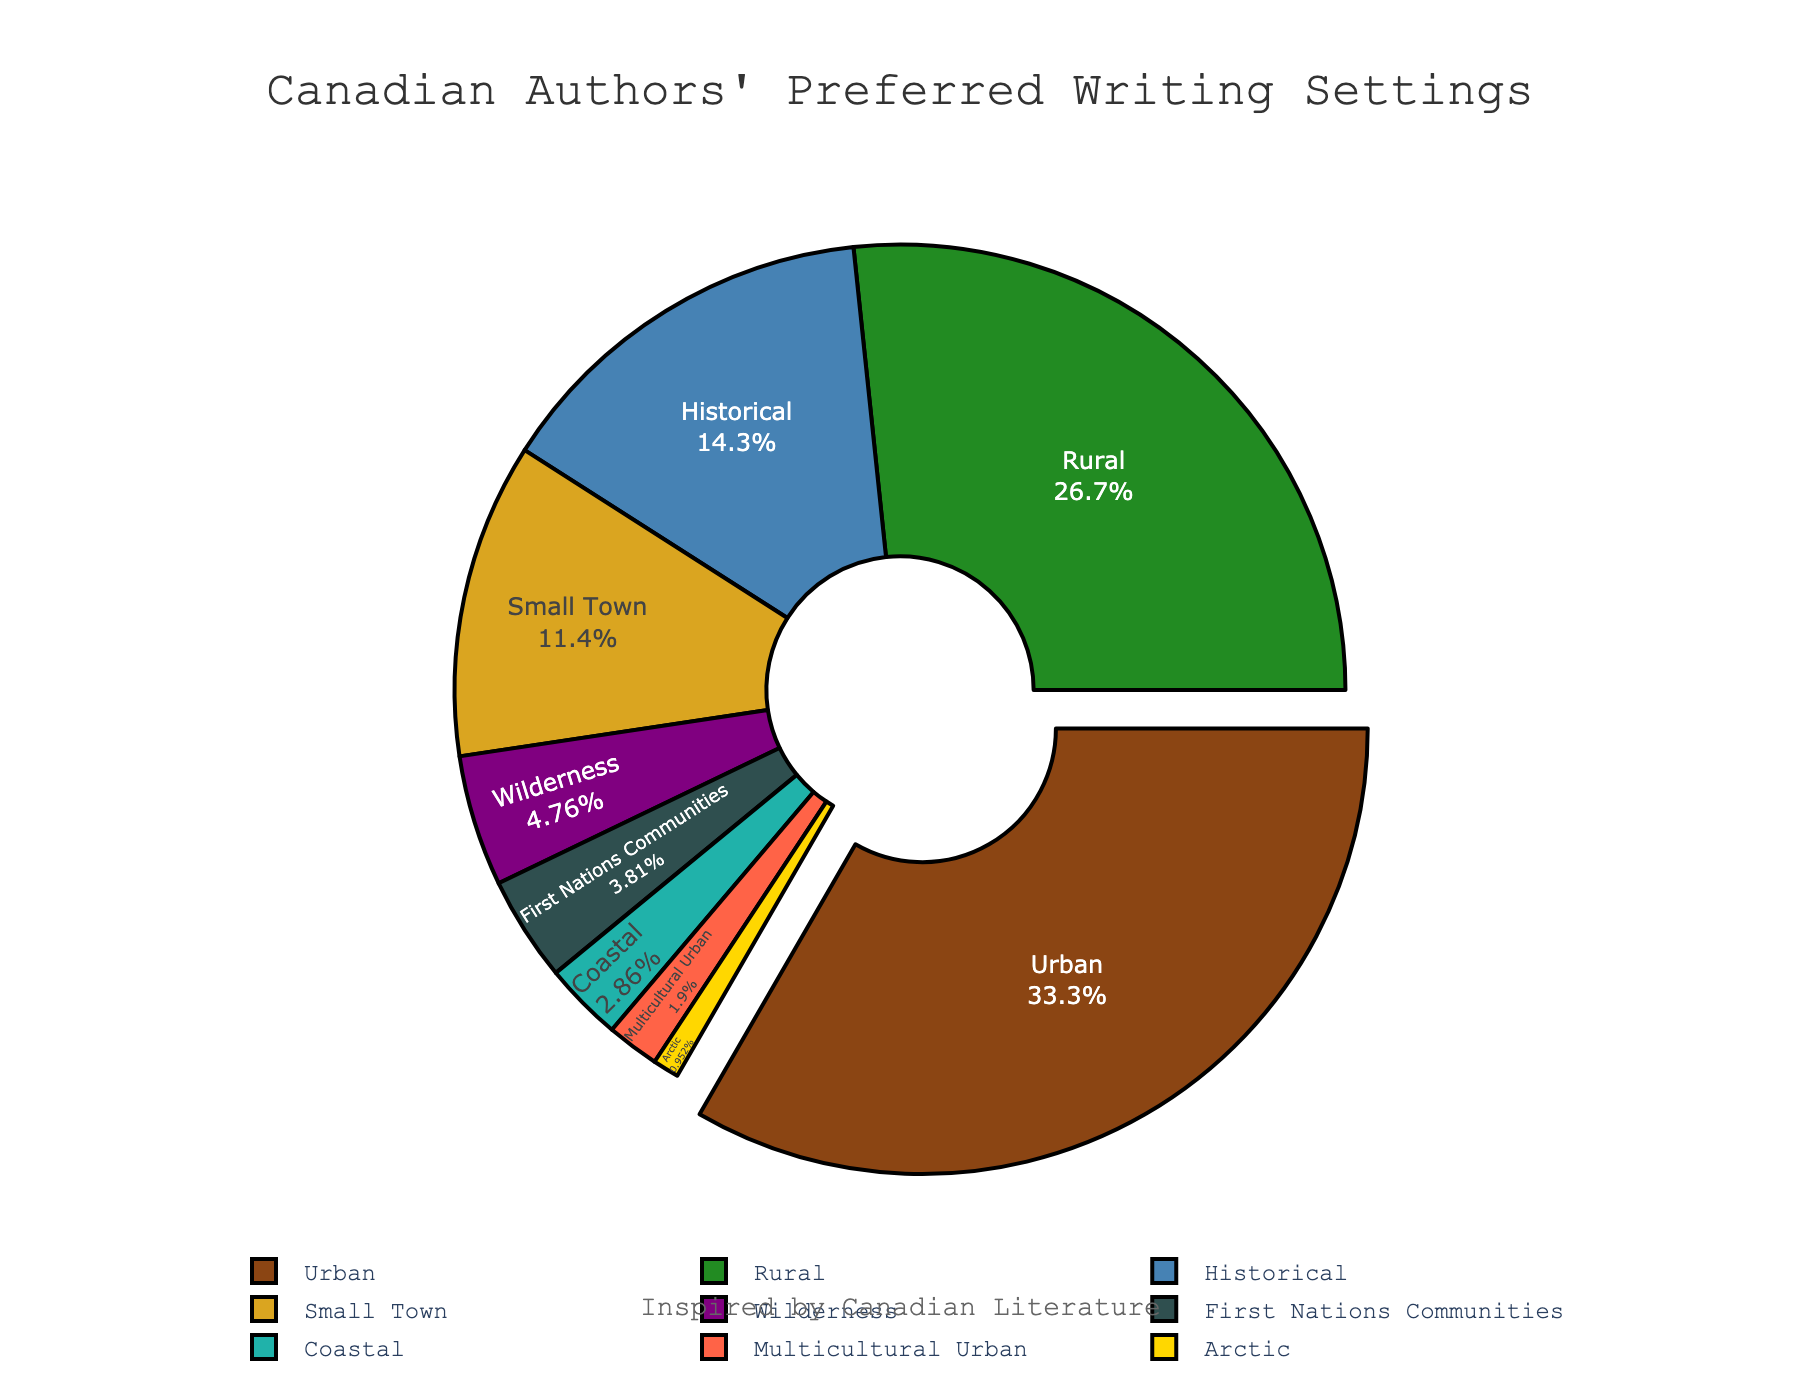What writing setting is most preferred by Canadian authors? The pie chart displays various writing settings, with "Urban" occupying the largest segment at 35%. This indicates that "Urban" is the most preferred writing setting by Canadian authors.
Answer: Urban Which writing setting has the least preference among Canadian authors? By looking at the smallest segment of the pie chart, it is clear that "Arctic" accounts for only 1%, making it the least preferred writing setting.
Answer: Arctic What is the combined percentage of authors who prefer Rural and Small Town settings? From the chart, Rural is at 28% and Small Town is at 12%. Adding these gives 28% + 12% = 40%.
Answer: 40% Which setting shows more preference, Historical or Wilderness, and by how much? The pie chart indicates Historical at 15% and Wilderness at 5%. To find the difference: 15% - 5% = 10%. Thus, Historical is preferred over Wilderness by 10%.
Answer: Historical by 10% Are there more authors who prefer Historical or Coastal settings combined than Urban settings? The percentage of authors preferring Historical is 15% and Coastal is 3%, summing to 15% + 3% = 18%. Compared to Urban at 35%, 18% is less than 35%, so the combined preference for Historical and Coastal is still less than Urban.
Answer: No What is the second least preferred setting among Canadian authors? The Arctic setting has the lowest preference at 1%, and the next smallest segment is "Multicultural Urban" at 2%. Therefore, the second least preferred setting is Multicultural Urban.
Answer: Multicultural Urban What is the total percentage of authors who prefer settings involving nature (Rural, Wilderness, Coastal, and Arctic)? Summing the percentages for Rural (28%), Wilderness (5%), Coastal (3%), and Arctic (1%): 28% + 5% + 3% + 1% = 37%.
Answer: 37% How much more popular is the Rural setting compared to the Combined setting for Small Town and First Nations Communities? Rural is 28%, Small Town is 12%, and First Nations Communities is 4%. Adding Small Town and First Nations gives 12% + 4% = 16%. Difference between Rural and combined setting: 28% - 16% = 12%.
Answer: 12% Which setting segment in the pie chart is visually pulled out, and why? The Urban segment is visually pulled out from the pie chart; this indicates it is the most significant segment, highlighting its highest percentage among all the settings.
Answer: Urban What's the combined percentage of authors who prefer settings that reflect Canadian heritage (Historical, First Nations Communities, and Arctic)? From the pie chart, Historical is 15%, First Nations Communities is 4%, and Arctic is 1%. Summing these gives: 15% + 4% + 1% = 20%.
Answer: 20% 